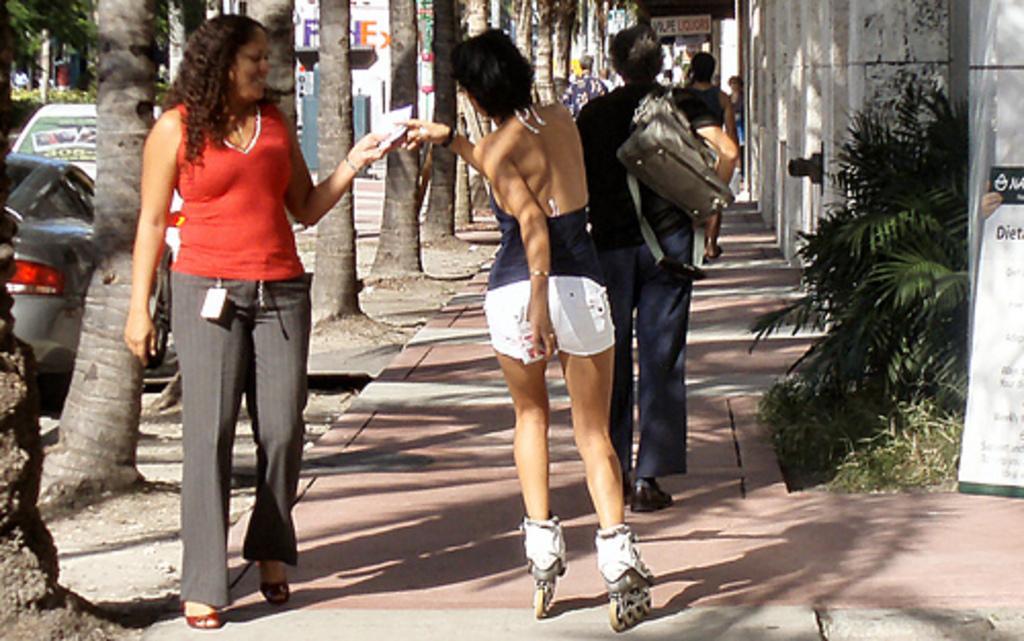In one or two sentences, can you explain what this image depicts? In the foreground of this image, there is a woman with skate shoes on the surface. On left, there is a woman in red T shirt and brown pant walking on the ground. On right, we see plant, banners, and the wall. On top, there is a crowd, trees, and vehicles. 